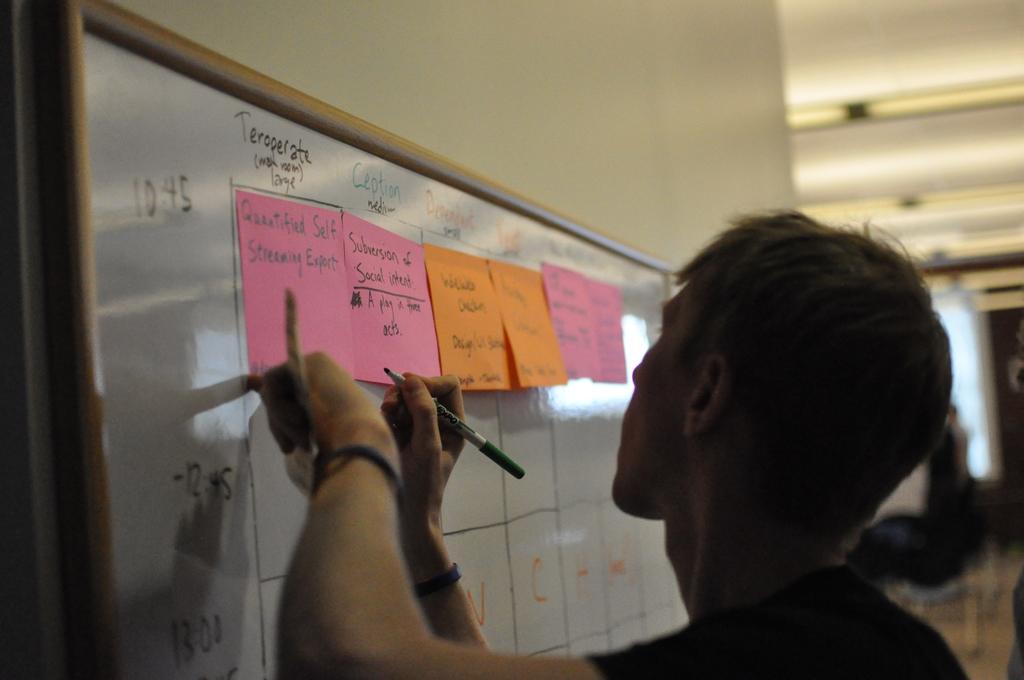What kind of expert is on the first pink post it?
Your response must be concise. Unanswerable. What numbers are written on the very top left of the board?
Your response must be concise. 10:45. 